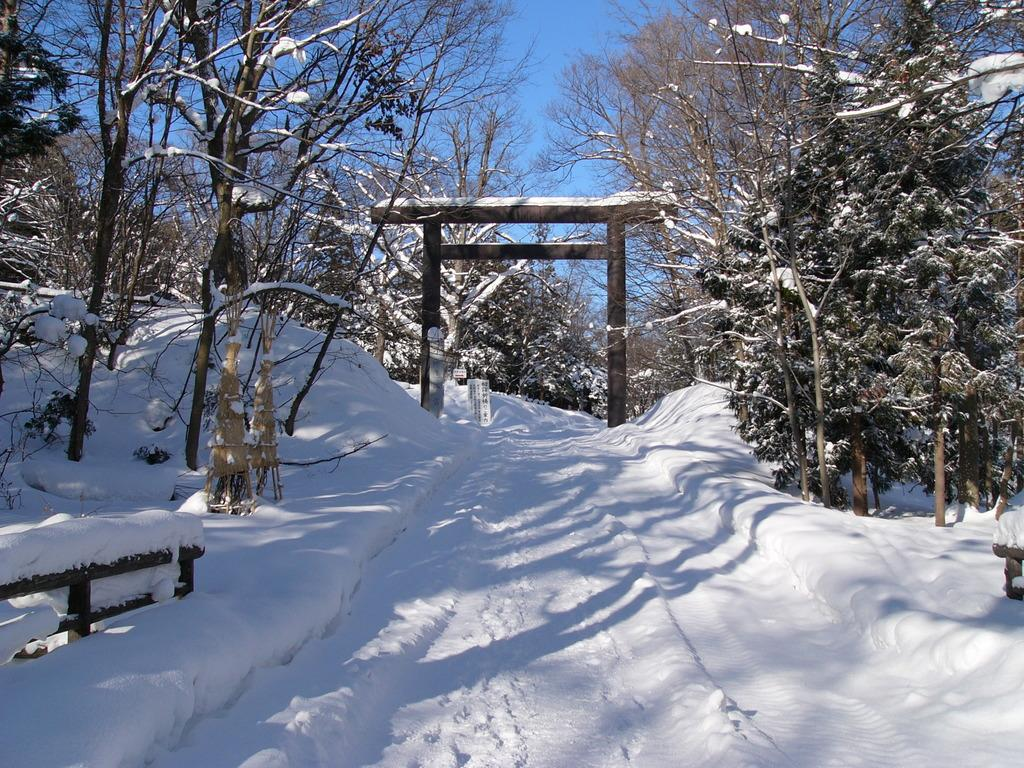What type of surface is visible in the image? There is a snow surface in the image. What can be seen surrounding the snow surface? There are many trees around the snow surface. How are the trees affected by the snow? The trees are covered with snow. What type of teeth can be seen on the actor in the image? There is no actor present in the image, and therefore no teeth can be observed. 